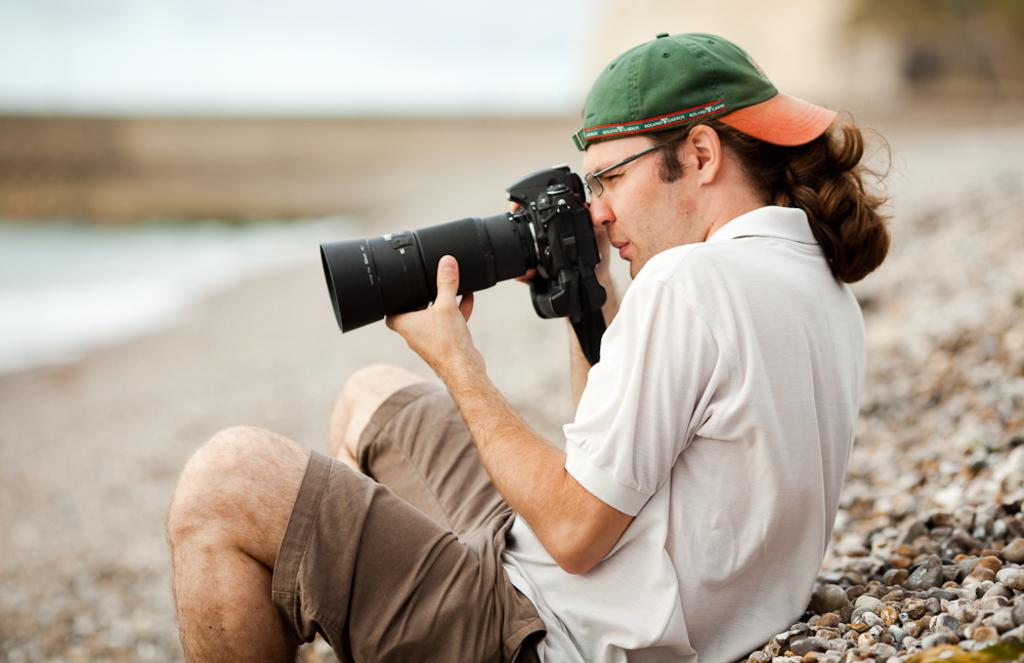What is the person in the image doing? The person is sitting in the image. What object is the person holding? The person is holding a camera. What type of headwear is the person wearing? The person is wearing a cap. What can be seen in the background of the image? The sky is visible in the image. What type of hose is being used to give advice to the person in the image? There is no hose or advice-giving in the image; it only features a person sitting and holding a camera. 